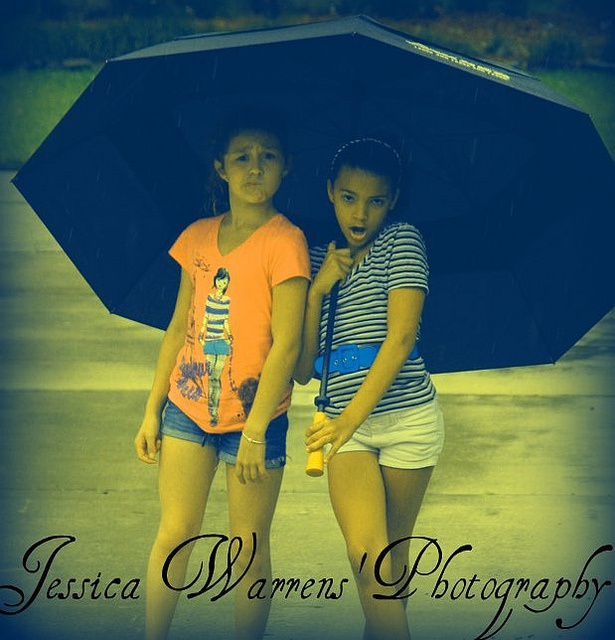Describe the objects in this image and their specific colors. I can see umbrella in navy and teal tones, people in navy, orange, olive, and darkgreen tones, and people in navy, olive, and darkgreen tones in this image. 